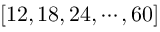<formula> <loc_0><loc_0><loc_500><loc_500>[ 1 2 , 1 8 , 2 4 , \cdots , 6 0 ]</formula> 